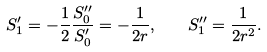<formula> <loc_0><loc_0><loc_500><loc_500>S ^ { \prime } _ { 1 } = - \frac { 1 } { 2 } \frac { S ^ { \prime \prime } _ { 0 } } { S ^ { \prime } _ { 0 } } = - \frac { 1 } { 2 r } , \quad S ^ { \prime \prime } _ { 1 } = \frac { 1 } { 2 r ^ { 2 } } .</formula> 